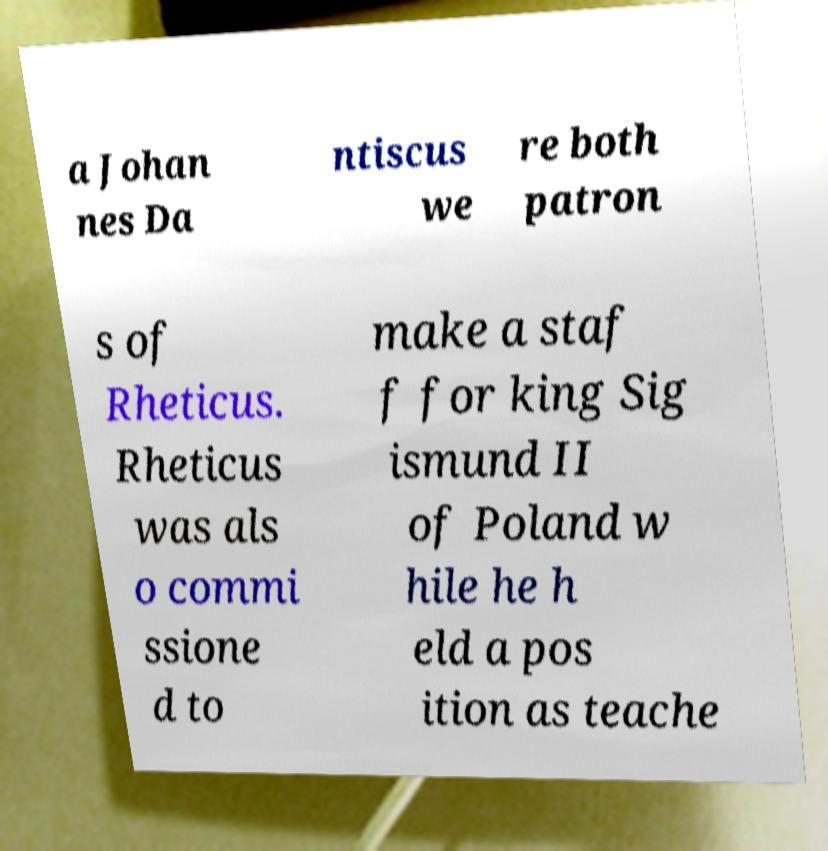What messages or text are displayed in this image? I need them in a readable, typed format. a Johan nes Da ntiscus we re both patron s of Rheticus. Rheticus was als o commi ssione d to make a staf f for king Sig ismund II of Poland w hile he h eld a pos ition as teache 